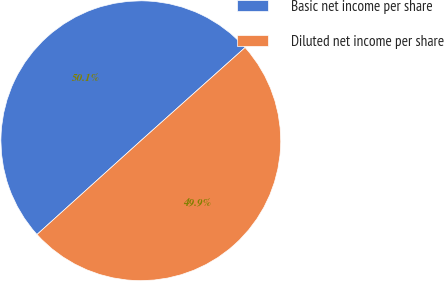<chart> <loc_0><loc_0><loc_500><loc_500><pie_chart><fcel>Basic net income per share<fcel>Diluted net income per share<nl><fcel>50.08%<fcel>49.92%<nl></chart> 